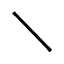Convert formula to latex. <formula><loc_0><loc_0><loc_500><loc_500>\diagdown</formula> 